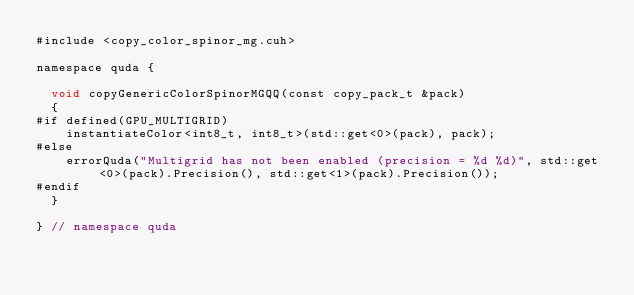Convert code to text. <code><loc_0><loc_0><loc_500><loc_500><_Cuda_>#include <copy_color_spinor_mg.cuh>

namespace quda {
  
  void copyGenericColorSpinorMGQQ(const copy_pack_t &pack)
  {
#if defined(GPU_MULTIGRID)
    instantiateColor<int8_t, int8_t>(std::get<0>(pack), pack);
#else
    errorQuda("Multigrid has not been enabled (precision = %d %d)", std::get<0>(pack).Precision(), std::get<1>(pack).Precision());
#endif
  }

} // namespace quda
</code> 